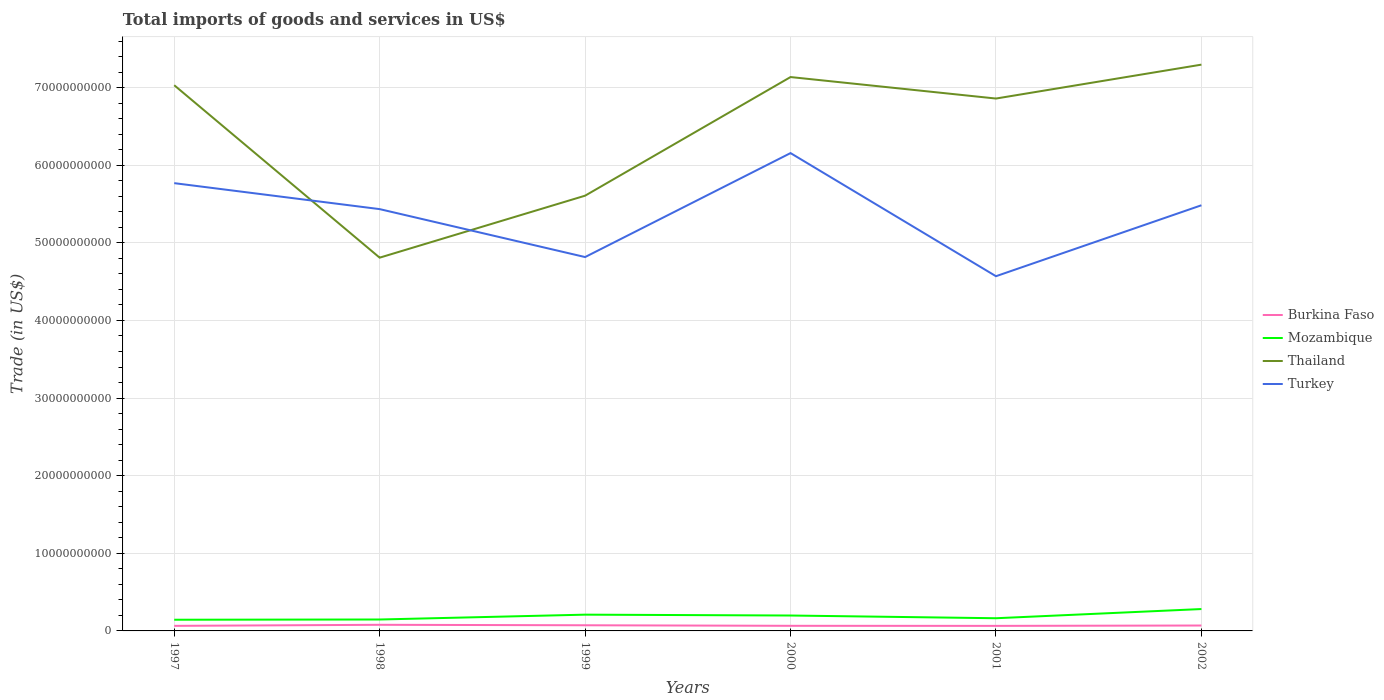How many different coloured lines are there?
Offer a terse response. 4. Does the line corresponding to Burkina Faso intersect with the line corresponding to Thailand?
Give a very brief answer. No. Is the number of lines equal to the number of legend labels?
Offer a terse response. Yes. Across all years, what is the maximum total imports of goods and services in Burkina Faso?
Your answer should be compact. 6.50e+08. What is the total total imports of goods and services in Turkey in the graph?
Ensure brevity in your answer.  -1.34e+1. What is the difference between the highest and the second highest total imports of goods and services in Thailand?
Offer a terse response. 2.49e+1. What is the difference between the highest and the lowest total imports of goods and services in Turkey?
Your answer should be very brief. 4. Is the total imports of goods and services in Thailand strictly greater than the total imports of goods and services in Mozambique over the years?
Your answer should be compact. No. How many years are there in the graph?
Your answer should be compact. 6. What is the difference between two consecutive major ticks on the Y-axis?
Provide a succinct answer. 1.00e+1. Does the graph contain any zero values?
Make the answer very short. No. Does the graph contain grids?
Your response must be concise. Yes. How many legend labels are there?
Your answer should be compact. 4. How are the legend labels stacked?
Make the answer very short. Vertical. What is the title of the graph?
Keep it short and to the point. Total imports of goods and services in US$. Does "Iceland" appear as one of the legend labels in the graph?
Keep it short and to the point. No. What is the label or title of the X-axis?
Ensure brevity in your answer.  Years. What is the label or title of the Y-axis?
Give a very brief answer. Trade (in US$). What is the Trade (in US$) in Burkina Faso in 1997?
Your answer should be compact. 6.51e+08. What is the Trade (in US$) of Mozambique in 1997?
Make the answer very short. 1.44e+09. What is the Trade (in US$) in Thailand in 1997?
Your answer should be very brief. 7.03e+1. What is the Trade (in US$) of Turkey in 1997?
Offer a terse response. 5.77e+1. What is the Trade (in US$) in Burkina Faso in 1998?
Give a very brief answer. 7.89e+08. What is the Trade (in US$) in Mozambique in 1998?
Offer a terse response. 1.47e+09. What is the Trade (in US$) of Thailand in 1998?
Give a very brief answer. 4.81e+1. What is the Trade (in US$) in Turkey in 1998?
Provide a short and direct response. 5.43e+1. What is the Trade (in US$) of Burkina Faso in 1999?
Your answer should be very brief. 7.29e+08. What is the Trade (in US$) of Mozambique in 1999?
Give a very brief answer. 2.10e+09. What is the Trade (in US$) in Thailand in 1999?
Offer a very short reply. 5.61e+1. What is the Trade (in US$) of Turkey in 1999?
Keep it short and to the point. 4.82e+1. What is the Trade (in US$) in Burkina Faso in 2000?
Provide a succinct answer. 6.58e+08. What is the Trade (in US$) in Mozambique in 2000?
Keep it short and to the point. 1.98e+09. What is the Trade (in US$) of Thailand in 2000?
Your answer should be compact. 7.14e+1. What is the Trade (in US$) in Turkey in 2000?
Ensure brevity in your answer.  6.16e+1. What is the Trade (in US$) of Burkina Faso in 2001?
Provide a succinct answer. 6.50e+08. What is the Trade (in US$) of Mozambique in 2001?
Keep it short and to the point. 1.64e+09. What is the Trade (in US$) in Thailand in 2001?
Your answer should be compact. 6.86e+1. What is the Trade (in US$) of Turkey in 2001?
Give a very brief answer. 4.57e+1. What is the Trade (in US$) of Burkina Faso in 2002?
Ensure brevity in your answer.  6.95e+08. What is the Trade (in US$) of Mozambique in 2002?
Make the answer very short. 2.82e+09. What is the Trade (in US$) of Thailand in 2002?
Your answer should be compact. 7.30e+1. What is the Trade (in US$) in Turkey in 2002?
Make the answer very short. 5.48e+1. Across all years, what is the maximum Trade (in US$) of Burkina Faso?
Your response must be concise. 7.89e+08. Across all years, what is the maximum Trade (in US$) of Mozambique?
Offer a very short reply. 2.82e+09. Across all years, what is the maximum Trade (in US$) in Thailand?
Ensure brevity in your answer.  7.30e+1. Across all years, what is the maximum Trade (in US$) in Turkey?
Your answer should be very brief. 6.16e+1. Across all years, what is the minimum Trade (in US$) of Burkina Faso?
Keep it short and to the point. 6.50e+08. Across all years, what is the minimum Trade (in US$) of Mozambique?
Your response must be concise. 1.44e+09. Across all years, what is the minimum Trade (in US$) of Thailand?
Your response must be concise. 4.81e+1. Across all years, what is the minimum Trade (in US$) of Turkey?
Provide a short and direct response. 4.57e+1. What is the total Trade (in US$) in Burkina Faso in the graph?
Your answer should be very brief. 4.17e+09. What is the total Trade (in US$) of Mozambique in the graph?
Ensure brevity in your answer.  1.14e+1. What is the total Trade (in US$) of Thailand in the graph?
Your answer should be very brief. 3.87e+11. What is the total Trade (in US$) of Turkey in the graph?
Offer a very short reply. 3.22e+11. What is the difference between the Trade (in US$) of Burkina Faso in 1997 and that in 1998?
Keep it short and to the point. -1.38e+08. What is the difference between the Trade (in US$) of Mozambique in 1997 and that in 1998?
Give a very brief answer. -3.12e+07. What is the difference between the Trade (in US$) of Thailand in 1997 and that in 1998?
Your answer should be very brief. 2.22e+1. What is the difference between the Trade (in US$) in Turkey in 1997 and that in 1998?
Your answer should be compact. 3.35e+09. What is the difference between the Trade (in US$) of Burkina Faso in 1997 and that in 1999?
Offer a terse response. -7.74e+07. What is the difference between the Trade (in US$) in Mozambique in 1997 and that in 1999?
Provide a succinct answer. -6.55e+08. What is the difference between the Trade (in US$) in Thailand in 1997 and that in 1999?
Offer a terse response. 1.42e+1. What is the difference between the Trade (in US$) of Turkey in 1997 and that in 1999?
Your answer should be compact. 9.52e+09. What is the difference between the Trade (in US$) in Burkina Faso in 1997 and that in 2000?
Offer a terse response. -6.47e+06. What is the difference between the Trade (in US$) of Mozambique in 1997 and that in 2000?
Your response must be concise. -5.44e+08. What is the difference between the Trade (in US$) of Thailand in 1997 and that in 2000?
Offer a very short reply. -1.05e+09. What is the difference between the Trade (in US$) in Turkey in 1997 and that in 2000?
Your response must be concise. -3.87e+09. What is the difference between the Trade (in US$) in Burkina Faso in 1997 and that in 2001?
Offer a terse response. 6.81e+05. What is the difference between the Trade (in US$) in Mozambique in 1997 and that in 2001?
Make the answer very short. -1.95e+08. What is the difference between the Trade (in US$) in Thailand in 1997 and that in 2001?
Ensure brevity in your answer.  1.72e+09. What is the difference between the Trade (in US$) of Turkey in 1997 and that in 2001?
Offer a very short reply. 1.20e+1. What is the difference between the Trade (in US$) in Burkina Faso in 1997 and that in 2002?
Keep it short and to the point. -4.43e+07. What is the difference between the Trade (in US$) in Mozambique in 1997 and that in 2002?
Your answer should be very brief. -1.38e+09. What is the difference between the Trade (in US$) in Thailand in 1997 and that in 2002?
Provide a succinct answer. -2.65e+09. What is the difference between the Trade (in US$) of Turkey in 1997 and that in 2002?
Your answer should be very brief. 2.85e+09. What is the difference between the Trade (in US$) in Burkina Faso in 1998 and that in 1999?
Your response must be concise. 6.05e+07. What is the difference between the Trade (in US$) of Mozambique in 1998 and that in 1999?
Give a very brief answer. -6.24e+08. What is the difference between the Trade (in US$) of Thailand in 1998 and that in 1999?
Provide a succinct answer. -7.99e+09. What is the difference between the Trade (in US$) of Turkey in 1998 and that in 1999?
Your answer should be compact. 6.18e+09. What is the difference between the Trade (in US$) in Burkina Faso in 1998 and that in 2000?
Your answer should be compact. 1.31e+08. What is the difference between the Trade (in US$) in Mozambique in 1998 and that in 2000?
Provide a succinct answer. -5.13e+08. What is the difference between the Trade (in US$) of Thailand in 1998 and that in 2000?
Ensure brevity in your answer.  -2.33e+1. What is the difference between the Trade (in US$) in Turkey in 1998 and that in 2000?
Your response must be concise. -7.22e+09. What is the difference between the Trade (in US$) of Burkina Faso in 1998 and that in 2001?
Keep it short and to the point. 1.39e+08. What is the difference between the Trade (in US$) of Mozambique in 1998 and that in 2001?
Keep it short and to the point. -1.63e+08. What is the difference between the Trade (in US$) in Thailand in 1998 and that in 2001?
Your answer should be very brief. -2.05e+1. What is the difference between the Trade (in US$) of Turkey in 1998 and that in 2001?
Your answer should be compact. 8.64e+09. What is the difference between the Trade (in US$) of Burkina Faso in 1998 and that in 2002?
Your answer should be very brief. 9.36e+07. What is the difference between the Trade (in US$) of Mozambique in 1998 and that in 2002?
Your response must be concise. -1.35e+09. What is the difference between the Trade (in US$) of Thailand in 1998 and that in 2002?
Provide a short and direct response. -2.49e+1. What is the difference between the Trade (in US$) in Turkey in 1998 and that in 2002?
Give a very brief answer. -4.95e+08. What is the difference between the Trade (in US$) in Burkina Faso in 1999 and that in 2000?
Your answer should be very brief. 7.09e+07. What is the difference between the Trade (in US$) in Mozambique in 1999 and that in 2000?
Give a very brief answer. 1.11e+08. What is the difference between the Trade (in US$) in Thailand in 1999 and that in 2000?
Your response must be concise. -1.53e+1. What is the difference between the Trade (in US$) in Turkey in 1999 and that in 2000?
Your response must be concise. -1.34e+1. What is the difference between the Trade (in US$) in Burkina Faso in 1999 and that in 2001?
Offer a terse response. 7.81e+07. What is the difference between the Trade (in US$) of Mozambique in 1999 and that in 2001?
Ensure brevity in your answer.  4.60e+08. What is the difference between the Trade (in US$) in Thailand in 1999 and that in 2001?
Provide a short and direct response. -1.25e+1. What is the difference between the Trade (in US$) in Turkey in 1999 and that in 2001?
Offer a terse response. 2.47e+09. What is the difference between the Trade (in US$) of Burkina Faso in 1999 and that in 2002?
Your answer should be very brief. 3.31e+07. What is the difference between the Trade (in US$) of Mozambique in 1999 and that in 2002?
Ensure brevity in your answer.  -7.22e+08. What is the difference between the Trade (in US$) in Thailand in 1999 and that in 2002?
Your response must be concise. -1.69e+1. What is the difference between the Trade (in US$) of Turkey in 1999 and that in 2002?
Provide a short and direct response. -6.67e+09. What is the difference between the Trade (in US$) of Burkina Faso in 2000 and that in 2001?
Offer a terse response. 7.15e+06. What is the difference between the Trade (in US$) of Mozambique in 2000 and that in 2001?
Your response must be concise. 3.50e+08. What is the difference between the Trade (in US$) in Thailand in 2000 and that in 2001?
Your answer should be very brief. 2.77e+09. What is the difference between the Trade (in US$) of Turkey in 2000 and that in 2001?
Provide a succinct answer. 1.59e+1. What is the difference between the Trade (in US$) in Burkina Faso in 2000 and that in 2002?
Provide a short and direct response. -3.78e+07. What is the difference between the Trade (in US$) in Mozambique in 2000 and that in 2002?
Your answer should be very brief. -8.33e+08. What is the difference between the Trade (in US$) of Thailand in 2000 and that in 2002?
Your answer should be compact. -1.60e+09. What is the difference between the Trade (in US$) in Turkey in 2000 and that in 2002?
Offer a terse response. 6.72e+09. What is the difference between the Trade (in US$) in Burkina Faso in 2001 and that in 2002?
Keep it short and to the point. -4.50e+07. What is the difference between the Trade (in US$) of Mozambique in 2001 and that in 2002?
Offer a terse response. -1.18e+09. What is the difference between the Trade (in US$) in Thailand in 2001 and that in 2002?
Provide a short and direct response. -4.37e+09. What is the difference between the Trade (in US$) of Turkey in 2001 and that in 2002?
Provide a succinct answer. -9.14e+09. What is the difference between the Trade (in US$) of Burkina Faso in 1997 and the Trade (in US$) of Mozambique in 1998?
Ensure brevity in your answer.  -8.21e+08. What is the difference between the Trade (in US$) in Burkina Faso in 1997 and the Trade (in US$) in Thailand in 1998?
Provide a succinct answer. -4.74e+1. What is the difference between the Trade (in US$) in Burkina Faso in 1997 and the Trade (in US$) in Turkey in 1998?
Provide a short and direct response. -5.37e+1. What is the difference between the Trade (in US$) of Mozambique in 1997 and the Trade (in US$) of Thailand in 1998?
Give a very brief answer. -4.66e+1. What is the difference between the Trade (in US$) in Mozambique in 1997 and the Trade (in US$) in Turkey in 1998?
Your response must be concise. -5.29e+1. What is the difference between the Trade (in US$) of Thailand in 1997 and the Trade (in US$) of Turkey in 1998?
Keep it short and to the point. 1.60e+1. What is the difference between the Trade (in US$) of Burkina Faso in 1997 and the Trade (in US$) of Mozambique in 1999?
Your answer should be very brief. -1.44e+09. What is the difference between the Trade (in US$) in Burkina Faso in 1997 and the Trade (in US$) in Thailand in 1999?
Ensure brevity in your answer.  -5.54e+1. What is the difference between the Trade (in US$) in Burkina Faso in 1997 and the Trade (in US$) in Turkey in 1999?
Keep it short and to the point. -4.75e+1. What is the difference between the Trade (in US$) in Mozambique in 1997 and the Trade (in US$) in Thailand in 1999?
Keep it short and to the point. -5.46e+1. What is the difference between the Trade (in US$) of Mozambique in 1997 and the Trade (in US$) of Turkey in 1999?
Your answer should be compact. -4.67e+1. What is the difference between the Trade (in US$) in Thailand in 1997 and the Trade (in US$) in Turkey in 1999?
Provide a short and direct response. 2.21e+1. What is the difference between the Trade (in US$) in Burkina Faso in 1997 and the Trade (in US$) in Mozambique in 2000?
Ensure brevity in your answer.  -1.33e+09. What is the difference between the Trade (in US$) of Burkina Faso in 1997 and the Trade (in US$) of Thailand in 2000?
Offer a terse response. -7.07e+1. What is the difference between the Trade (in US$) in Burkina Faso in 1997 and the Trade (in US$) in Turkey in 2000?
Your response must be concise. -6.09e+1. What is the difference between the Trade (in US$) in Mozambique in 1997 and the Trade (in US$) in Thailand in 2000?
Provide a succinct answer. -6.99e+1. What is the difference between the Trade (in US$) of Mozambique in 1997 and the Trade (in US$) of Turkey in 2000?
Offer a very short reply. -6.01e+1. What is the difference between the Trade (in US$) in Thailand in 1997 and the Trade (in US$) in Turkey in 2000?
Provide a short and direct response. 8.74e+09. What is the difference between the Trade (in US$) of Burkina Faso in 1997 and the Trade (in US$) of Mozambique in 2001?
Your answer should be compact. -9.84e+08. What is the difference between the Trade (in US$) of Burkina Faso in 1997 and the Trade (in US$) of Thailand in 2001?
Make the answer very short. -6.79e+1. What is the difference between the Trade (in US$) of Burkina Faso in 1997 and the Trade (in US$) of Turkey in 2001?
Give a very brief answer. -4.50e+1. What is the difference between the Trade (in US$) of Mozambique in 1997 and the Trade (in US$) of Thailand in 2001?
Your answer should be very brief. -6.71e+1. What is the difference between the Trade (in US$) of Mozambique in 1997 and the Trade (in US$) of Turkey in 2001?
Offer a very short reply. -4.43e+1. What is the difference between the Trade (in US$) in Thailand in 1997 and the Trade (in US$) in Turkey in 2001?
Give a very brief answer. 2.46e+1. What is the difference between the Trade (in US$) in Burkina Faso in 1997 and the Trade (in US$) in Mozambique in 2002?
Ensure brevity in your answer.  -2.17e+09. What is the difference between the Trade (in US$) in Burkina Faso in 1997 and the Trade (in US$) in Thailand in 2002?
Make the answer very short. -7.23e+1. What is the difference between the Trade (in US$) in Burkina Faso in 1997 and the Trade (in US$) in Turkey in 2002?
Offer a very short reply. -5.42e+1. What is the difference between the Trade (in US$) of Mozambique in 1997 and the Trade (in US$) of Thailand in 2002?
Your answer should be very brief. -7.15e+1. What is the difference between the Trade (in US$) of Mozambique in 1997 and the Trade (in US$) of Turkey in 2002?
Offer a very short reply. -5.34e+1. What is the difference between the Trade (in US$) of Thailand in 1997 and the Trade (in US$) of Turkey in 2002?
Your answer should be very brief. 1.55e+1. What is the difference between the Trade (in US$) of Burkina Faso in 1998 and the Trade (in US$) of Mozambique in 1999?
Offer a very short reply. -1.31e+09. What is the difference between the Trade (in US$) of Burkina Faso in 1998 and the Trade (in US$) of Thailand in 1999?
Give a very brief answer. -5.53e+1. What is the difference between the Trade (in US$) in Burkina Faso in 1998 and the Trade (in US$) in Turkey in 1999?
Provide a short and direct response. -4.74e+1. What is the difference between the Trade (in US$) of Mozambique in 1998 and the Trade (in US$) of Thailand in 1999?
Keep it short and to the point. -5.46e+1. What is the difference between the Trade (in US$) of Mozambique in 1998 and the Trade (in US$) of Turkey in 1999?
Ensure brevity in your answer.  -4.67e+1. What is the difference between the Trade (in US$) of Thailand in 1998 and the Trade (in US$) of Turkey in 1999?
Offer a terse response. -7.87e+07. What is the difference between the Trade (in US$) in Burkina Faso in 1998 and the Trade (in US$) in Mozambique in 2000?
Provide a succinct answer. -1.20e+09. What is the difference between the Trade (in US$) in Burkina Faso in 1998 and the Trade (in US$) in Thailand in 2000?
Make the answer very short. -7.06e+1. What is the difference between the Trade (in US$) of Burkina Faso in 1998 and the Trade (in US$) of Turkey in 2000?
Offer a terse response. -6.08e+1. What is the difference between the Trade (in US$) in Mozambique in 1998 and the Trade (in US$) in Thailand in 2000?
Ensure brevity in your answer.  -6.99e+1. What is the difference between the Trade (in US$) in Mozambique in 1998 and the Trade (in US$) in Turkey in 2000?
Offer a very short reply. -6.01e+1. What is the difference between the Trade (in US$) in Thailand in 1998 and the Trade (in US$) in Turkey in 2000?
Keep it short and to the point. -1.35e+1. What is the difference between the Trade (in US$) in Burkina Faso in 1998 and the Trade (in US$) in Mozambique in 2001?
Give a very brief answer. -8.46e+08. What is the difference between the Trade (in US$) of Burkina Faso in 1998 and the Trade (in US$) of Thailand in 2001?
Keep it short and to the point. -6.78e+1. What is the difference between the Trade (in US$) of Burkina Faso in 1998 and the Trade (in US$) of Turkey in 2001?
Provide a short and direct response. -4.49e+1. What is the difference between the Trade (in US$) of Mozambique in 1998 and the Trade (in US$) of Thailand in 2001?
Keep it short and to the point. -6.71e+1. What is the difference between the Trade (in US$) of Mozambique in 1998 and the Trade (in US$) of Turkey in 2001?
Your answer should be compact. -4.42e+1. What is the difference between the Trade (in US$) of Thailand in 1998 and the Trade (in US$) of Turkey in 2001?
Ensure brevity in your answer.  2.39e+09. What is the difference between the Trade (in US$) in Burkina Faso in 1998 and the Trade (in US$) in Mozambique in 2002?
Your response must be concise. -2.03e+09. What is the difference between the Trade (in US$) of Burkina Faso in 1998 and the Trade (in US$) of Thailand in 2002?
Ensure brevity in your answer.  -7.22e+1. What is the difference between the Trade (in US$) of Burkina Faso in 1998 and the Trade (in US$) of Turkey in 2002?
Provide a short and direct response. -5.40e+1. What is the difference between the Trade (in US$) in Mozambique in 1998 and the Trade (in US$) in Thailand in 2002?
Your answer should be very brief. -7.15e+1. What is the difference between the Trade (in US$) of Mozambique in 1998 and the Trade (in US$) of Turkey in 2002?
Offer a terse response. -5.34e+1. What is the difference between the Trade (in US$) in Thailand in 1998 and the Trade (in US$) in Turkey in 2002?
Provide a short and direct response. -6.75e+09. What is the difference between the Trade (in US$) of Burkina Faso in 1999 and the Trade (in US$) of Mozambique in 2000?
Your response must be concise. -1.26e+09. What is the difference between the Trade (in US$) in Burkina Faso in 1999 and the Trade (in US$) in Thailand in 2000?
Offer a terse response. -7.06e+1. What is the difference between the Trade (in US$) in Burkina Faso in 1999 and the Trade (in US$) in Turkey in 2000?
Offer a terse response. -6.08e+1. What is the difference between the Trade (in US$) of Mozambique in 1999 and the Trade (in US$) of Thailand in 2000?
Make the answer very short. -6.93e+1. What is the difference between the Trade (in US$) of Mozambique in 1999 and the Trade (in US$) of Turkey in 2000?
Offer a terse response. -5.95e+1. What is the difference between the Trade (in US$) in Thailand in 1999 and the Trade (in US$) in Turkey in 2000?
Provide a short and direct response. -5.49e+09. What is the difference between the Trade (in US$) in Burkina Faso in 1999 and the Trade (in US$) in Mozambique in 2001?
Keep it short and to the point. -9.06e+08. What is the difference between the Trade (in US$) of Burkina Faso in 1999 and the Trade (in US$) of Thailand in 2001?
Ensure brevity in your answer.  -6.79e+1. What is the difference between the Trade (in US$) of Burkina Faso in 1999 and the Trade (in US$) of Turkey in 2001?
Offer a terse response. -4.50e+1. What is the difference between the Trade (in US$) of Mozambique in 1999 and the Trade (in US$) of Thailand in 2001?
Provide a short and direct response. -6.65e+1. What is the difference between the Trade (in US$) of Mozambique in 1999 and the Trade (in US$) of Turkey in 2001?
Make the answer very short. -4.36e+1. What is the difference between the Trade (in US$) of Thailand in 1999 and the Trade (in US$) of Turkey in 2001?
Provide a succinct answer. 1.04e+1. What is the difference between the Trade (in US$) of Burkina Faso in 1999 and the Trade (in US$) of Mozambique in 2002?
Your answer should be compact. -2.09e+09. What is the difference between the Trade (in US$) in Burkina Faso in 1999 and the Trade (in US$) in Thailand in 2002?
Ensure brevity in your answer.  -7.22e+1. What is the difference between the Trade (in US$) in Burkina Faso in 1999 and the Trade (in US$) in Turkey in 2002?
Ensure brevity in your answer.  -5.41e+1. What is the difference between the Trade (in US$) of Mozambique in 1999 and the Trade (in US$) of Thailand in 2002?
Ensure brevity in your answer.  -7.09e+1. What is the difference between the Trade (in US$) of Mozambique in 1999 and the Trade (in US$) of Turkey in 2002?
Ensure brevity in your answer.  -5.27e+1. What is the difference between the Trade (in US$) of Thailand in 1999 and the Trade (in US$) of Turkey in 2002?
Provide a short and direct response. 1.24e+09. What is the difference between the Trade (in US$) in Burkina Faso in 2000 and the Trade (in US$) in Mozambique in 2001?
Ensure brevity in your answer.  -9.77e+08. What is the difference between the Trade (in US$) in Burkina Faso in 2000 and the Trade (in US$) in Thailand in 2001?
Give a very brief answer. -6.79e+1. What is the difference between the Trade (in US$) in Burkina Faso in 2000 and the Trade (in US$) in Turkey in 2001?
Keep it short and to the point. -4.50e+1. What is the difference between the Trade (in US$) of Mozambique in 2000 and the Trade (in US$) of Thailand in 2001?
Your response must be concise. -6.66e+1. What is the difference between the Trade (in US$) in Mozambique in 2000 and the Trade (in US$) in Turkey in 2001?
Ensure brevity in your answer.  -4.37e+1. What is the difference between the Trade (in US$) in Thailand in 2000 and the Trade (in US$) in Turkey in 2001?
Offer a terse response. 2.57e+1. What is the difference between the Trade (in US$) in Burkina Faso in 2000 and the Trade (in US$) in Mozambique in 2002?
Ensure brevity in your answer.  -2.16e+09. What is the difference between the Trade (in US$) in Burkina Faso in 2000 and the Trade (in US$) in Thailand in 2002?
Give a very brief answer. -7.23e+1. What is the difference between the Trade (in US$) of Burkina Faso in 2000 and the Trade (in US$) of Turkey in 2002?
Your answer should be compact. -5.42e+1. What is the difference between the Trade (in US$) of Mozambique in 2000 and the Trade (in US$) of Thailand in 2002?
Offer a very short reply. -7.10e+1. What is the difference between the Trade (in US$) of Mozambique in 2000 and the Trade (in US$) of Turkey in 2002?
Ensure brevity in your answer.  -5.29e+1. What is the difference between the Trade (in US$) of Thailand in 2000 and the Trade (in US$) of Turkey in 2002?
Ensure brevity in your answer.  1.65e+1. What is the difference between the Trade (in US$) in Burkina Faso in 2001 and the Trade (in US$) in Mozambique in 2002?
Provide a succinct answer. -2.17e+09. What is the difference between the Trade (in US$) of Burkina Faso in 2001 and the Trade (in US$) of Thailand in 2002?
Ensure brevity in your answer.  -7.23e+1. What is the difference between the Trade (in US$) of Burkina Faso in 2001 and the Trade (in US$) of Turkey in 2002?
Offer a very short reply. -5.42e+1. What is the difference between the Trade (in US$) in Mozambique in 2001 and the Trade (in US$) in Thailand in 2002?
Offer a terse response. -7.13e+1. What is the difference between the Trade (in US$) in Mozambique in 2001 and the Trade (in US$) in Turkey in 2002?
Give a very brief answer. -5.32e+1. What is the difference between the Trade (in US$) in Thailand in 2001 and the Trade (in US$) in Turkey in 2002?
Your response must be concise. 1.38e+1. What is the average Trade (in US$) of Burkina Faso per year?
Your answer should be very brief. 6.95e+08. What is the average Trade (in US$) of Mozambique per year?
Your response must be concise. 1.91e+09. What is the average Trade (in US$) of Thailand per year?
Your answer should be compact. 6.46e+1. What is the average Trade (in US$) of Turkey per year?
Provide a succinct answer. 5.37e+1. In the year 1997, what is the difference between the Trade (in US$) in Burkina Faso and Trade (in US$) in Mozambique?
Provide a short and direct response. -7.89e+08. In the year 1997, what is the difference between the Trade (in US$) in Burkina Faso and Trade (in US$) in Thailand?
Your answer should be very brief. -6.97e+1. In the year 1997, what is the difference between the Trade (in US$) in Burkina Faso and Trade (in US$) in Turkey?
Make the answer very short. -5.70e+1. In the year 1997, what is the difference between the Trade (in US$) of Mozambique and Trade (in US$) of Thailand?
Your answer should be very brief. -6.89e+1. In the year 1997, what is the difference between the Trade (in US$) of Mozambique and Trade (in US$) of Turkey?
Offer a very short reply. -5.62e+1. In the year 1997, what is the difference between the Trade (in US$) of Thailand and Trade (in US$) of Turkey?
Make the answer very short. 1.26e+1. In the year 1998, what is the difference between the Trade (in US$) in Burkina Faso and Trade (in US$) in Mozambique?
Your answer should be compact. -6.83e+08. In the year 1998, what is the difference between the Trade (in US$) in Burkina Faso and Trade (in US$) in Thailand?
Your answer should be compact. -4.73e+1. In the year 1998, what is the difference between the Trade (in US$) in Burkina Faso and Trade (in US$) in Turkey?
Offer a terse response. -5.36e+1. In the year 1998, what is the difference between the Trade (in US$) in Mozambique and Trade (in US$) in Thailand?
Provide a short and direct response. -4.66e+1. In the year 1998, what is the difference between the Trade (in US$) of Mozambique and Trade (in US$) of Turkey?
Provide a succinct answer. -5.29e+1. In the year 1998, what is the difference between the Trade (in US$) in Thailand and Trade (in US$) in Turkey?
Ensure brevity in your answer.  -6.25e+09. In the year 1999, what is the difference between the Trade (in US$) of Burkina Faso and Trade (in US$) of Mozambique?
Give a very brief answer. -1.37e+09. In the year 1999, what is the difference between the Trade (in US$) of Burkina Faso and Trade (in US$) of Thailand?
Your answer should be very brief. -5.53e+1. In the year 1999, what is the difference between the Trade (in US$) of Burkina Faso and Trade (in US$) of Turkey?
Provide a short and direct response. -4.74e+1. In the year 1999, what is the difference between the Trade (in US$) of Mozambique and Trade (in US$) of Thailand?
Provide a succinct answer. -5.40e+1. In the year 1999, what is the difference between the Trade (in US$) of Mozambique and Trade (in US$) of Turkey?
Offer a terse response. -4.61e+1. In the year 1999, what is the difference between the Trade (in US$) in Thailand and Trade (in US$) in Turkey?
Keep it short and to the point. 7.91e+09. In the year 2000, what is the difference between the Trade (in US$) in Burkina Faso and Trade (in US$) in Mozambique?
Make the answer very short. -1.33e+09. In the year 2000, what is the difference between the Trade (in US$) of Burkina Faso and Trade (in US$) of Thailand?
Your answer should be very brief. -7.07e+1. In the year 2000, what is the difference between the Trade (in US$) in Burkina Faso and Trade (in US$) in Turkey?
Keep it short and to the point. -6.09e+1. In the year 2000, what is the difference between the Trade (in US$) of Mozambique and Trade (in US$) of Thailand?
Ensure brevity in your answer.  -6.94e+1. In the year 2000, what is the difference between the Trade (in US$) in Mozambique and Trade (in US$) in Turkey?
Keep it short and to the point. -5.96e+1. In the year 2000, what is the difference between the Trade (in US$) in Thailand and Trade (in US$) in Turkey?
Offer a very short reply. 9.80e+09. In the year 2001, what is the difference between the Trade (in US$) in Burkina Faso and Trade (in US$) in Mozambique?
Offer a terse response. -9.85e+08. In the year 2001, what is the difference between the Trade (in US$) in Burkina Faso and Trade (in US$) in Thailand?
Give a very brief answer. -6.79e+1. In the year 2001, what is the difference between the Trade (in US$) of Burkina Faso and Trade (in US$) of Turkey?
Ensure brevity in your answer.  -4.50e+1. In the year 2001, what is the difference between the Trade (in US$) in Mozambique and Trade (in US$) in Thailand?
Make the answer very short. -6.70e+1. In the year 2001, what is the difference between the Trade (in US$) of Mozambique and Trade (in US$) of Turkey?
Provide a short and direct response. -4.41e+1. In the year 2001, what is the difference between the Trade (in US$) of Thailand and Trade (in US$) of Turkey?
Your answer should be compact. 2.29e+1. In the year 2002, what is the difference between the Trade (in US$) of Burkina Faso and Trade (in US$) of Mozambique?
Your response must be concise. -2.12e+09. In the year 2002, what is the difference between the Trade (in US$) of Burkina Faso and Trade (in US$) of Thailand?
Your answer should be compact. -7.23e+1. In the year 2002, what is the difference between the Trade (in US$) in Burkina Faso and Trade (in US$) in Turkey?
Make the answer very short. -5.41e+1. In the year 2002, what is the difference between the Trade (in US$) of Mozambique and Trade (in US$) of Thailand?
Offer a terse response. -7.01e+1. In the year 2002, what is the difference between the Trade (in US$) in Mozambique and Trade (in US$) in Turkey?
Provide a short and direct response. -5.20e+1. In the year 2002, what is the difference between the Trade (in US$) in Thailand and Trade (in US$) in Turkey?
Ensure brevity in your answer.  1.81e+1. What is the ratio of the Trade (in US$) in Burkina Faso in 1997 to that in 1998?
Your response must be concise. 0.83. What is the ratio of the Trade (in US$) of Mozambique in 1997 to that in 1998?
Offer a very short reply. 0.98. What is the ratio of the Trade (in US$) of Thailand in 1997 to that in 1998?
Your response must be concise. 1.46. What is the ratio of the Trade (in US$) in Turkey in 1997 to that in 1998?
Offer a very short reply. 1.06. What is the ratio of the Trade (in US$) in Burkina Faso in 1997 to that in 1999?
Make the answer very short. 0.89. What is the ratio of the Trade (in US$) of Mozambique in 1997 to that in 1999?
Offer a terse response. 0.69. What is the ratio of the Trade (in US$) in Thailand in 1997 to that in 1999?
Provide a succinct answer. 1.25. What is the ratio of the Trade (in US$) of Turkey in 1997 to that in 1999?
Offer a very short reply. 1.2. What is the ratio of the Trade (in US$) of Burkina Faso in 1997 to that in 2000?
Make the answer very short. 0.99. What is the ratio of the Trade (in US$) in Mozambique in 1997 to that in 2000?
Your answer should be very brief. 0.73. What is the ratio of the Trade (in US$) in Thailand in 1997 to that in 2000?
Offer a very short reply. 0.99. What is the ratio of the Trade (in US$) in Turkey in 1997 to that in 2000?
Make the answer very short. 0.94. What is the ratio of the Trade (in US$) of Burkina Faso in 1997 to that in 2001?
Offer a terse response. 1. What is the ratio of the Trade (in US$) in Mozambique in 1997 to that in 2001?
Offer a terse response. 0.88. What is the ratio of the Trade (in US$) in Thailand in 1997 to that in 2001?
Ensure brevity in your answer.  1.02. What is the ratio of the Trade (in US$) of Turkey in 1997 to that in 2001?
Your answer should be very brief. 1.26. What is the ratio of the Trade (in US$) of Burkina Faso in 1997 to that in 2002?
Offer a very short reply. 0.94. What is the ratio of the Trade (in US$) of Mozambique in 1997 to that in 2002?
Your answer should be compact. 0.51. What is the ratio of the Trade (in US$) in Thailand in 1997 to that in 2002?
Keep it short and to the point. 0.96. What is the ratio of the Trade (in US$) of Turkey in 1997 to that in 2002?
Ensure brevity in your answer.  1.05. What is the ratio of the Trade (in US$) in Burkina Faso in 1998 to that in 1999?
Give a very brief answer. 1.08. What is the ratio of the Trade (in US$) in Mozambique in 1998 to that in 1999?
Your answer should be very brief. 0.7. What is the ratio of the Trade (in US$) in Thailand in 1998 to that in 1999?
Ensure brevity in your answer.  0.86. What is the ratio of the Trade (in US$) in Turkey in 1998 to that in 1999?
Give a very brief answer. 1.13. What is the ratio of the Trade (in US$) in Burkina Faso in 1998 to that in 2000?
Your response must be concise. 1.2. What is the ratio of the Trade (in US$) of Mozambique in 1998 to that in 2000?
Make the answer very short. 0.74. What is the ratio of the Trade (in US$) of Thailand in 1998 to that in 2000?
Keep it short and to the point. 0.67. What is the ratio of the Trade (in US$) of Turkey in 1998 to that in 2000?
Your response must be concise. 0.88. What is the ratio of the Trade (in US$) in Burkina Faso in 1998 to that in 2001?
Ensure brevity in your answer.  1.21. What is the ratio of the Trade (in US$) of Mozambique in 1998 to that in 2001?
Your answer should be compact. 0.9. What is the ratio of the Trade (in US$) in Thailand in 1998 to that in 2001?
Your answer should be very brief. 0.7. What is the ratio of the Trade (in US$) in Turkey in 1998 to that in 2001?
Provide a short and direct response. 1.19. What is the ratio of the Trade (in US$) of Burkina Faso in 1998 to that in 2002?
Ensure brevity in your answer.  1.13. What is the ratio of the Trade (in US$) of Mozambique in 1998 to that in 2002?
Your response must be concise. 0.52. What is the ratio of the Trade (in US$) of Thailand in 1998 to that in 2002?
Offer a very short reply. 0.66. What is the ratio of the Trade (in US$) in Burkina Faso in 1999 to that in 2000?
Provide a short and direct response. 1.11. What is the ratio of the Trade (in US$) of Mozambique in 1999 to that in 2000?
Provide a succinct answer. 1.06. What is the ratio of the Trade (in US$) in Thailand in 1999 to that in 2000?
Your answer should be very brief. 0.79. What is the ratio of the Trade (in US$) of Turkey in 1999 to that in 2000?
Keep it short and to the point. 0.78. What is the ratio of the Trade (in US$) in Burkina Faso in 1999 to that in 2001?
Ensure brevity in your answer.  1.12. What is the ratio of the Trade (in US$) in Mozambique in 1999 to that in 2001?
Offer a very short reply. 1.28. What is the ratio of the Trade (in US$) in Thailand in 1999 to that in 2001?
Ensure brevity in your answer.  0.82. What is the ratio of the Trade (in US$) in Turkey in 1999 to that in 2001?
Keep it short and to the point. 1.05. What is the ratio of the Trade (in US$) in Burkina Faso in 1999 to that in 2002?
Provide a succinct answer. 1.05. What is the ratio of the Trade (in US$) in Mozambique in 1999 to that in 2002?
Give a very brief answer. 0.74. What is the ratio of the Trade (in US$) in Thailand in 1999 to that in 2002?
Provide a succinct answer. 0.77. What is the ratio of the Trade (in US$) of Turkey in 1999 to that in 2002?
Give a very brief answer. 0.88. What is the ratio of the Trade (in US$) of Burkina Faso in 2000 to that in 2001?
Your answer should be compact. 1.01. What is the ratio of the Trade (in US$) in Mozambique in 2000 to that in 2001?
Your answer should be compact. 1.21. What is the ratio of the Trade (in US$) in Thailand in 2000 to that in 2001?
Ensure brevity in your answer.  1.04. What is the ratio of the Trade (in US$) in Turkey in 2000 to that in 2001?
Keep it short and to the point. 1.35. What is the ratio of the Trade (in US$) of Burkina Faso in 2000 to that in 2002?
Keep it short and to the point. 0.95. What is the ratio of the Trade (in US$) of Mozambique in 2000 to that in 2002?
Offer a very short reply. 0.7. What is the ratio of the Trade (in US$) of Thailand in 2000 to that in 2002?
Your response must be concise. 0.98. What is the ratio of the Trade (in US$) of Turkey in 2000 to that in 2002?
Provide a short and direct response. 1.12. What is the ratio of the Trade (in US$) in Burkina Faso in 2001 to that in 2002?
Your answer should be very brief. 0.94. What is the ratio of the Trade (in US$) of Mozambique in 2001 to that in 2002?
Provide a short and direct response. 0.58. What is the ratio of the Trade (in US$) in Thailand in 2001 to that in 2002?
Make the answer very short. 0.94. What is the ratio of the Trade (in US$) of Turkey in 2001 to that in 2002?
Your response must be concise. 0.83. What is the difference between the highest and the second highest Trade (in US$) of Burkina Faso?
Offer a terse response. 6.05e+07. What is the difference between the highest and the second highest Trade (in US$) of Mozambique?
Your response must be concise. 7.22e+08. What is the difference between the highest and the second highest Trade (in US$) in Thailand?
Make the answer very short. 1.60e+09. What is the difference between the highest and the second highest Trade (in US$) in Turkey?
Make the answer very short. 3.87e+09. What is the difference between the highest and the lowest Trade (in US$) of Burkina Faso?
Provide a succinct answer. 1.39e+08. What is the difference between the highest and the lowest Trade (in US$) in Mozambique?
Make the answer very short. 1.38e+09. What is the difference between the highest and the lowest Trade (in US$) of Thailand?
Make the answer very short. 2.49e+1. What is the difference between the highest and the lowest Trade (in US$) of Turkey?
Give a very brief answer. 1.59e+1. 